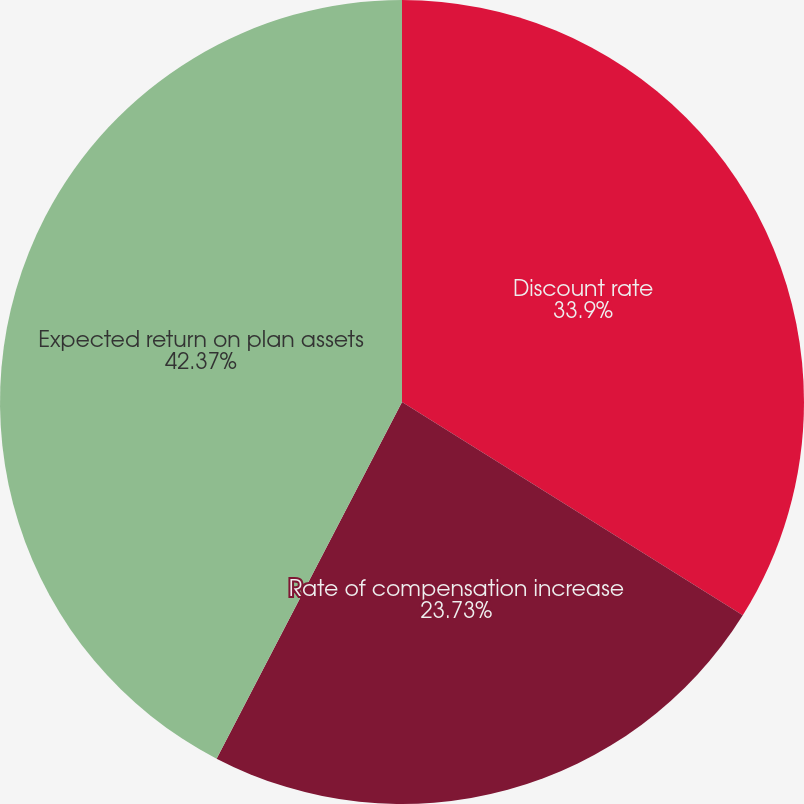Convert chart. <chart><loc_0><loc_0><loc_500><loc_500><pie_chart><fcel>Discount rate<fcel>Rate of compensation increase<fcel>Expected return on plan assets<nl><fcel>33.9%<fcel>23.73%<fcel>42.37%<nl></chart> 